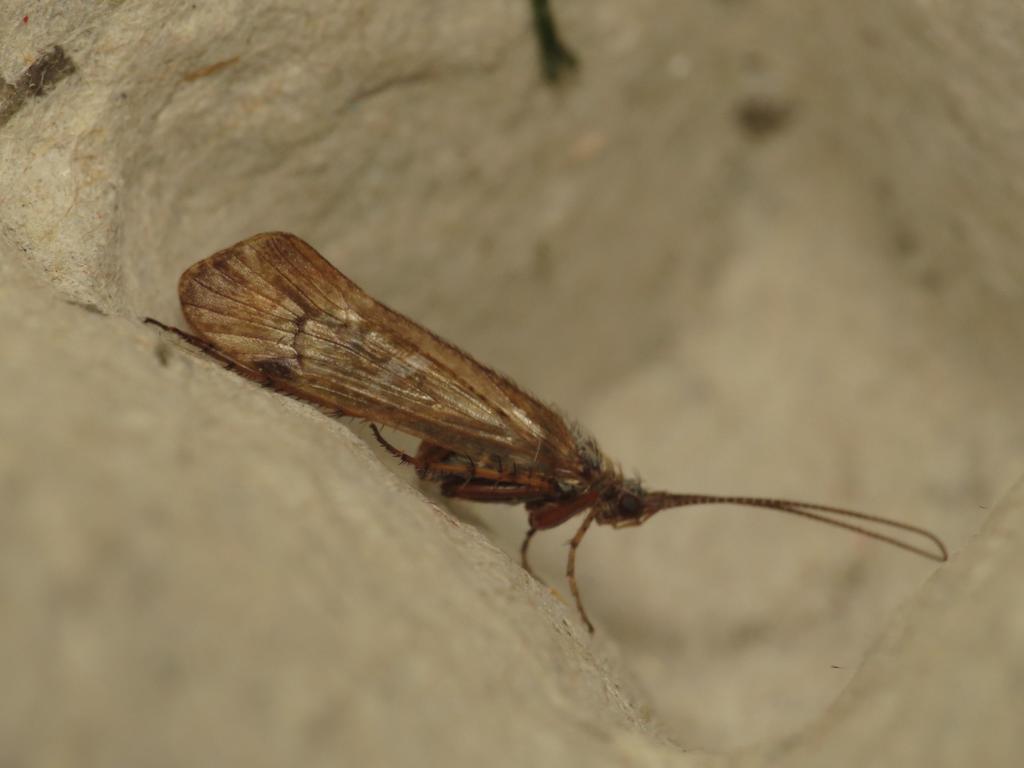Please provide a concise description of this image. In this image I can see an insect in brown color and it is on the cream and white color surface. 